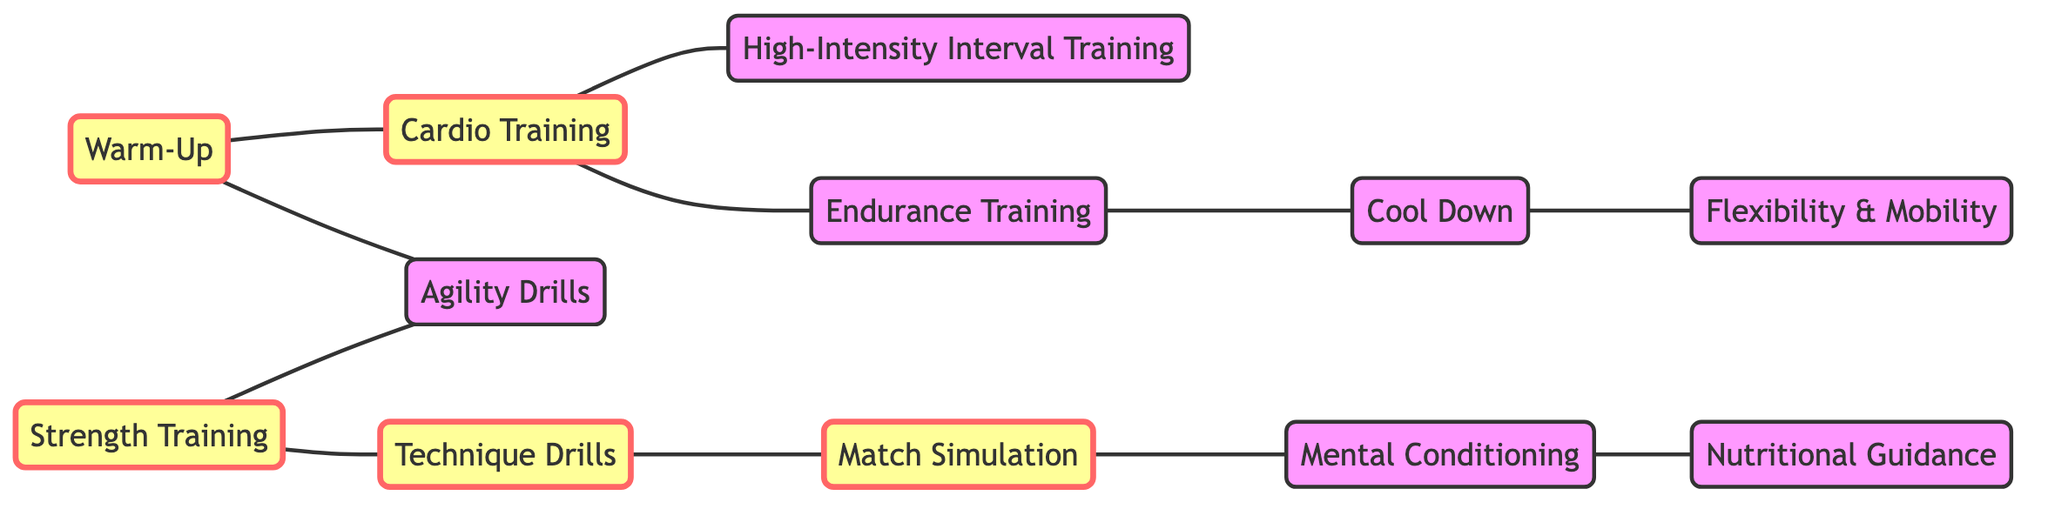What are the total number of nodes in the diagram? To find the total number of nodes, we can count each unique training component listed in the data. The nodes include Warm-Up, Cardio Training, Strength Training, Technique Drills, Match Simulation, Cool Down, High-Intensity Interval Training, Agility Drills, Endurance Training, Flexibility & Mobility, Mental Conditioning, and Nutritional Guidance, which totals to 12 nodes.
Answer: 12 Which exercise connects directly to Match Simulation? By examining the connections (edges) in the diagram, we see that Technique Drills connects directly to Match Simulation, indicating that Technique Drills is an exercise that leads to Match Simulation.
Answer: Technique Drills How many edges are in the diagram? To determine the number of edges, we count each unique relationship between the nodes as described in the edges section. There are 11 edges listed, which represent the connections between different training components.
Answer: 11 What is the relationship between Cardio Training and Endurance Training? Looking at the diagram, Cardio Training has a direct connection (edge) to Endurance Training, indicating that they are linked in the training regimen. This means Cardio Training includes components that involve Endurance Training.
Answer: Direct connection Which training area is a prerequisite for High-Intensity Interval Training? By analyzing the edges, we find that Cardio Training must precede High-Intensity Interval Training, as there is an edge from Cardio Training to High-Intensity Interval Training indicating this flow in the training regimen.
Answer: Cardio Training Can you identify a pair of exercises that are connected to Warm-Up? Warm-Up connects to both Cardio Training and Agility Drills, creating direct connections based on the edges that originate from Warm-Up. These exercises are thus prerequisites in the coaching program following the Warm-Up phase.
Answer: Cardio Training, Agility Drills Is Nutritional Guidance part of a direct link to Mental Conditioning? Yes, the diagram shows a direct edge from Mental Conditioning to Nutritional Guidance, meaning that in the training network, Mental Conditioning leads into or includes a focus on Nutritional Guidance.
Answer: Yes What is the endpoint for the Cool Down exercise in the network? Following the edges, Cool Down connects to Flexibility & Mobility, indicating that Flexibility & Mobility is the next step or conclusion of the training regimen after the Cool Down phase.
Answer: Flexibility & Mobility 